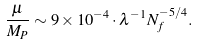Convert formula to latex. <formula><loc_0><loc_0><loc_500><loc_500>\frac { \mu } { M _ { P } } \sim 9 \times 1 0 ^ { - 4 } \cdot \lambda ^ { - 1 } N _ { f } ^ { - 5 / 4 } .</formula> 